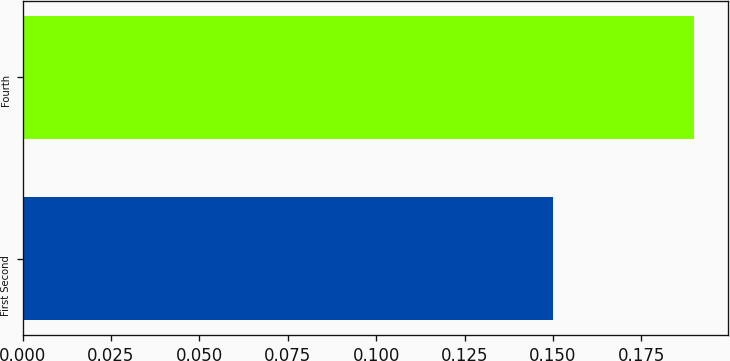Convert chart. <chart><loc_0><loc_0><loc_500><loc_500><bar_chart><fcel>First Second<fcel>Fourth<nl><fcel>0.15<fcel>0.19<nl></chart> 